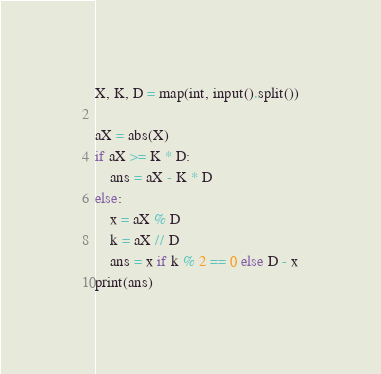Convert code to text. <code><loc_0><loc_0><loc_500><loc_500><_Python_>X, K, D = map(int, input().split())

aX = abs(X)
if aX >= K * D:
    ans = aX - K * D
else:
    x = aX % D
    k = aX // D
    ans = x if k % 2 == 0 else D - x
print(ans)
</code> 